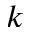<formula> <loc_0><loc_0><loc_500><loc_500>k</formula> 